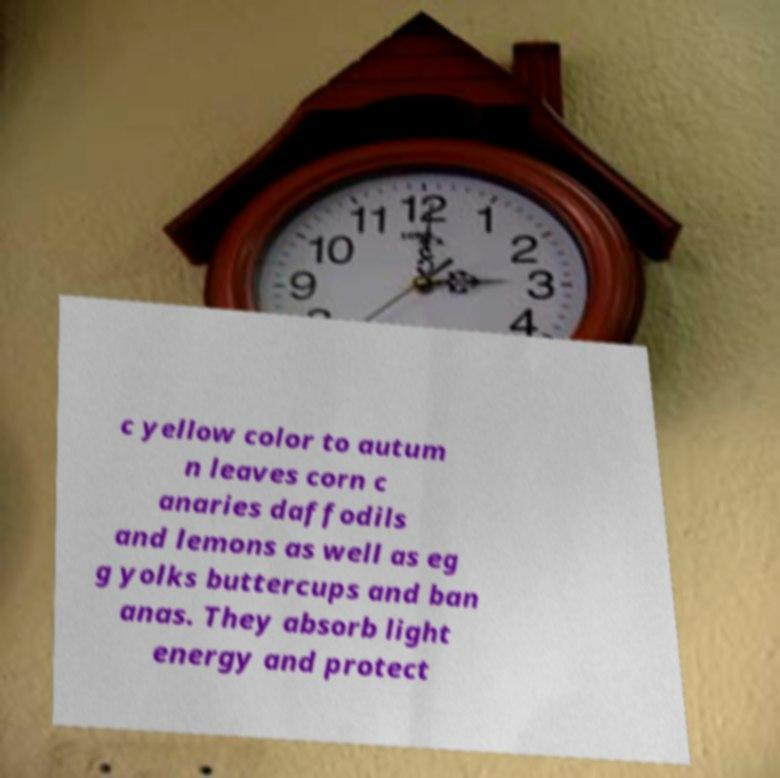Please read and relay the text visible in this image. What does it say? c yellow color to autum n leaves corn c anaries daffodils and lemons as well as eg g yolks buttercups and ban anas. They absorb light energy and protect 